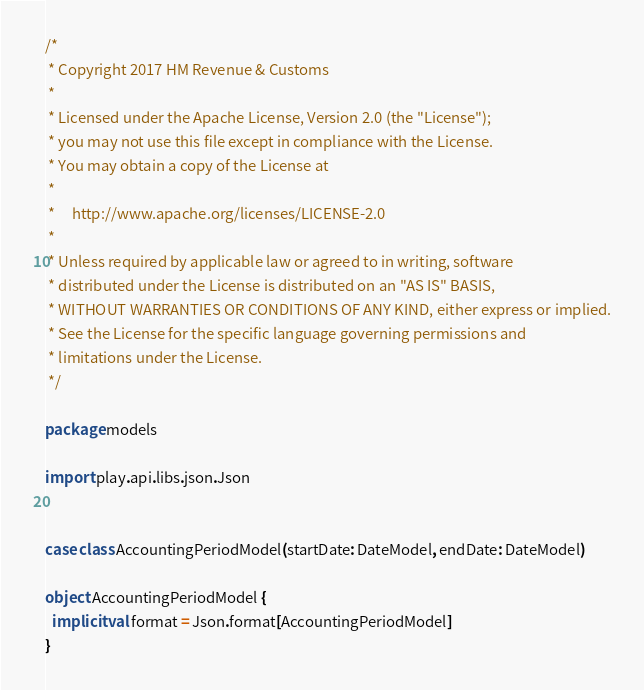Convert code to text. <code><loc_0><loc_0><loc_500><loc_500><_Scala_>/*
 * Copyright 2017 HM Revenue & Customs
 *
 * Licensed under the Apache License, Version 2.0 (the "License");
 * you may not use this file except in compliance with the License.
 * You may obtain a copy of the License at
 *
 *     http://www.apache.org/licenses/LICENSE-2.0
 *
 * Unless required by applicable law or agreed to in writing, software
 * distributed under the License is distributed on an "AS IS" BASIS,
 * WITHOUT WARRANTIES OR CONDITIONS OF ANY KIND, either express or implied.
 * See the License for the specific language governing permissions and
 * limitations under the License.
 */

package models

import play.api.libs.json.Json


case class AccountingPeriodModel(startDate: DateModel, endDate: DateModel)

object AccountingPeriodModel {
  implicit val format = Json.format[AccountingPeriodModel]
}
</code> 